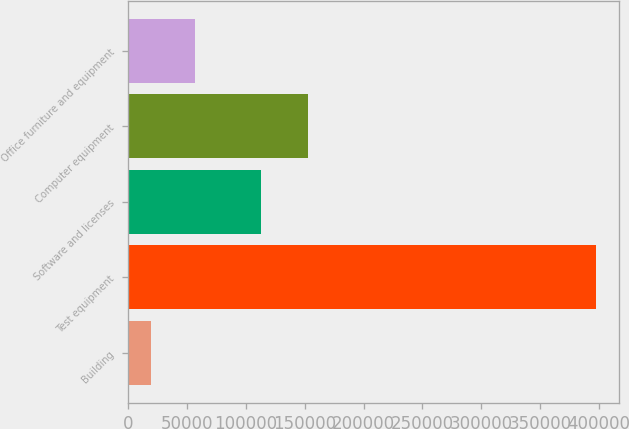<chart> <loc_0><loc_0><loc_500><loc_500><bar_chart><fcel>Building<fcel>Test equipment<fcel>Software and licenses<fcel>Computer equipment<fcel>Office furniture and equipment<nl><fcel>19268<fcel>397319<fcel>112967<fcel>152733<fcel>57073.1<nl></chart> 